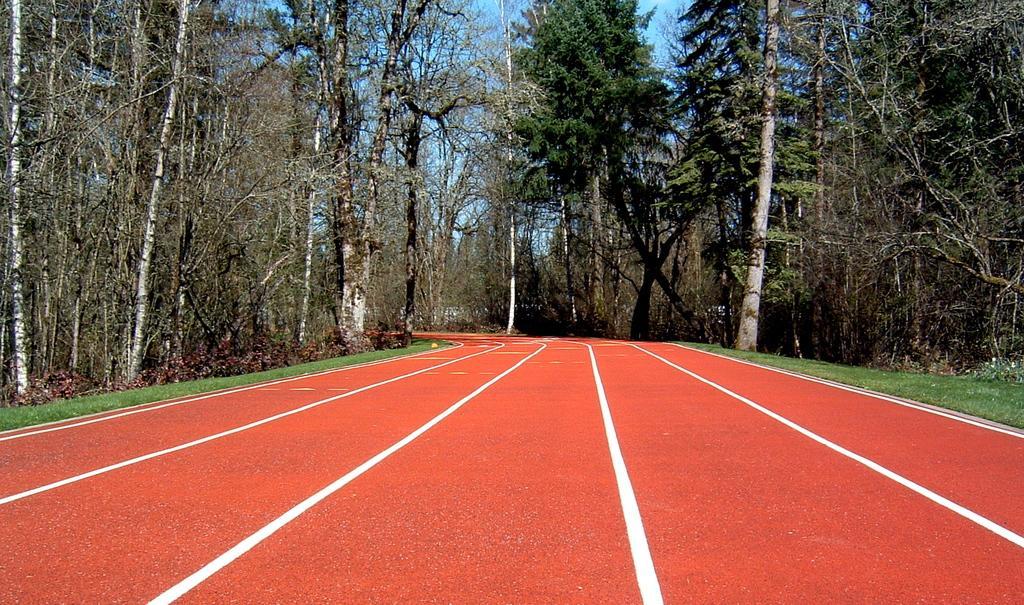Can you describe this image briefly? In this image at the bottom there is road and grass, and in the background there are some trees and at the top of the image there is sky. 